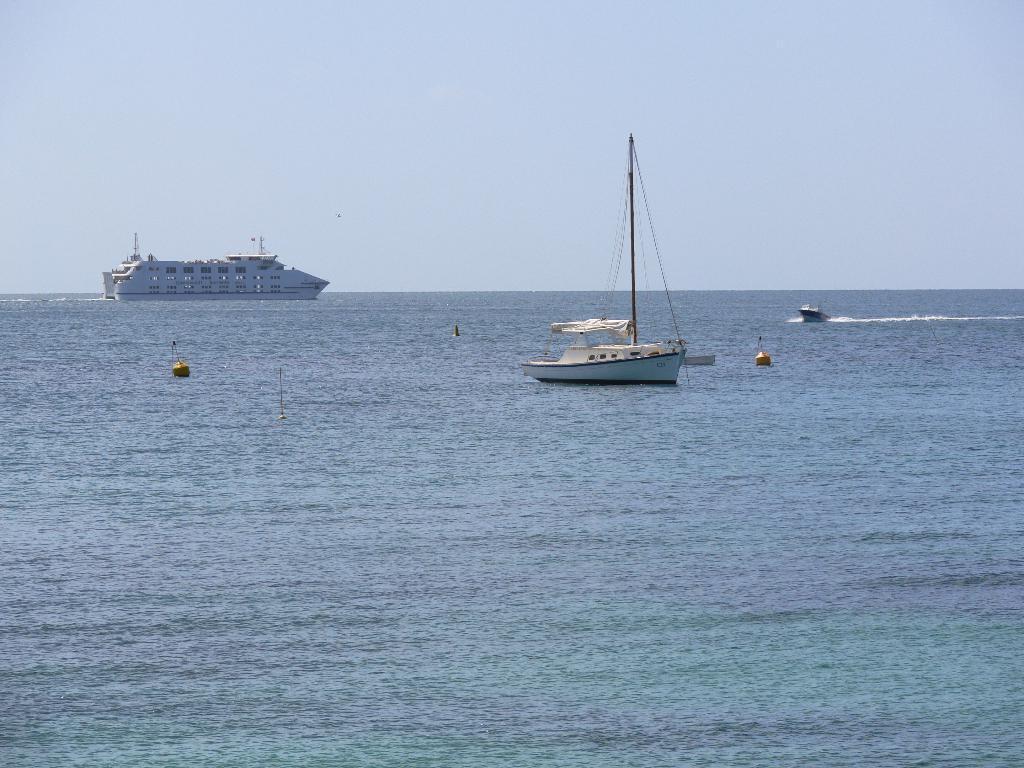How would you summarize this image in a sentence or two? In this image there is a sea in the bottom of this image. There is a ship as we can see on the left side of this image and one more is in the middle of this image. There is a boat on the right side of this image. There is a sky on the top of this image. 